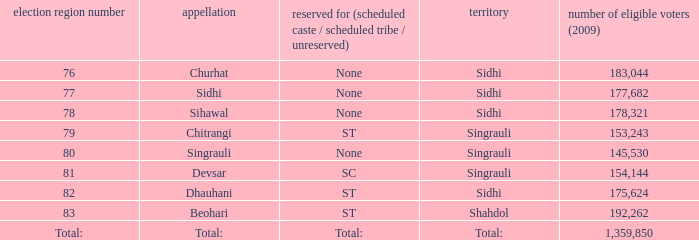What is the district with 79 constituency number? Singrauli. 